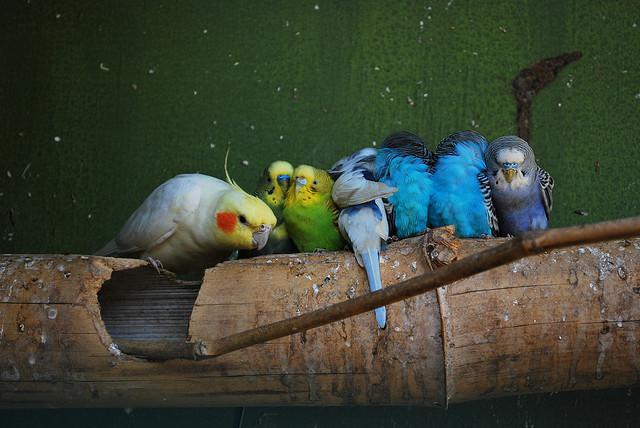What type of bird is the one on the far left? Please explain your reasoning. cockatiel. Its head defines it. 